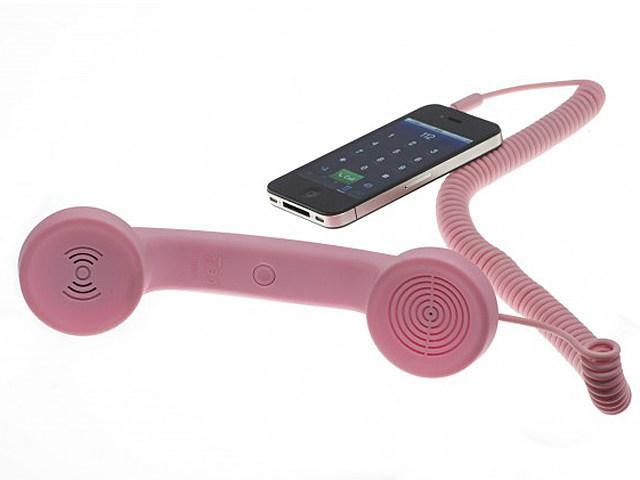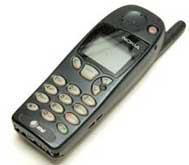The first image is the image on the left, the second image is the image on the right. Considering the images on both sides, is "There are three objects." valid? Answer yes or no. Yes. The first image is the image on the left, the second image is the image on the right. Given the left and right images, does the statement "One of the phones is connected to an old fashioned handset." hold true? Answer yes or no. Yes. 